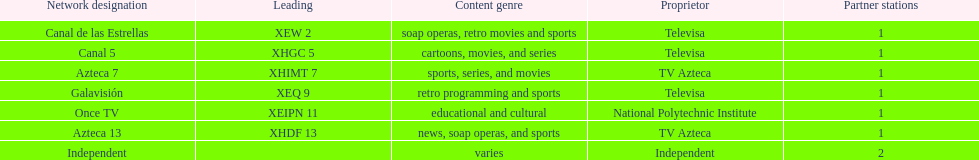What is the average number of affiliates that a given network will have? 1. 